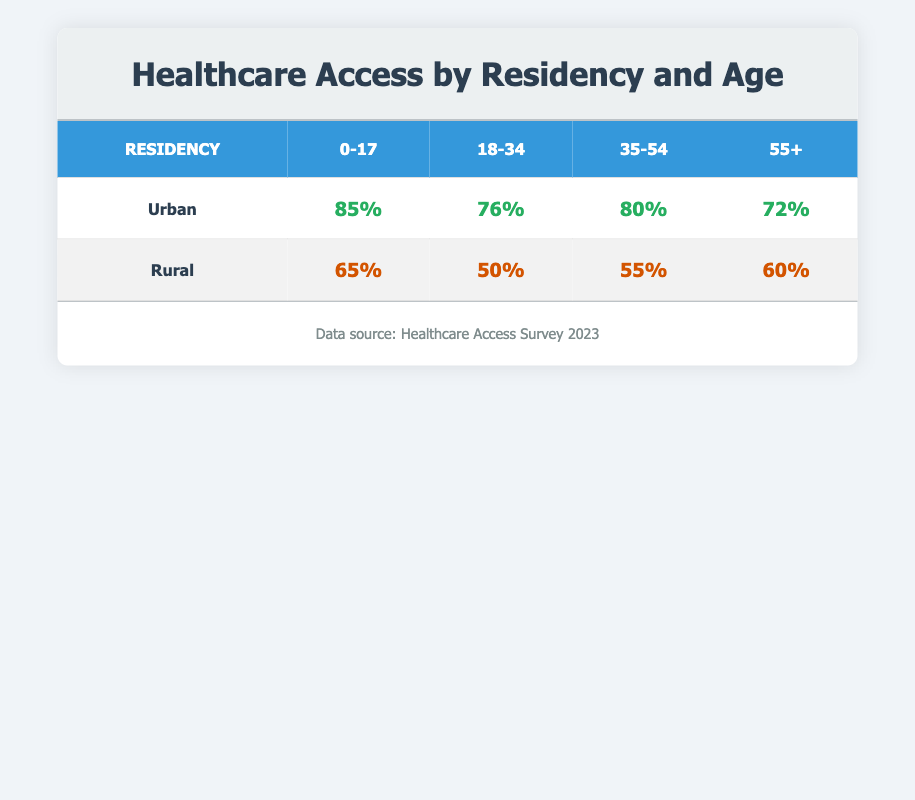What is the healthcare access percentage for Urban residents aged 0-17? The table shows that Urban residents in the age group 0-17 have a healthcare access percentage of 85%.
Answer: 85% What is the healthcare access percentage for Rural residents aged 18-34? According to the table, Rural residents aged 18-34 have a healthcare access percentage of 50%.
Answer: 50% Is the healthcare access for Urban residents aged 55+ higher than that for Rural residents in the same age group? The table presents that Urban residents aged 55+ have a healthcare access percentage of 72%, while Rural residents have 60%. Since 72% is greater than 60%, the statement is true.
Answer: Yes What is the difference in healthcare access percentage between Urban residents aged 0-17 and Rural residents aged 0-17? The access percentage for Urban residents aged 0-17 is 85%, and for Rural residents, it is 65%. The difference is 85% - 65% = 20%.
Answer: 20% What is the average healthcare access percentage for the Urban residency across all age groups? The percentages for Urban residents are: 85%, 76%, 80%, and 72%. Adding these gives 313%, and dividing by 4 age groups gives an average of 313% / 4 = 78.25%.
Answer: 78.25% Is the healthcare access rate for the age group 35-54 higher in Urban or Rural residency? The Urban access rate for the age group 35-54 is 80%, while the Rural rate is 55%. Since 80% is higher than 55%, Urban residency has a higher rate for this age group.
Answer: Yes What is the total healthcare access percentage for all Rural age groups combined? To find the total, add the healthcare access percentages for Rural residents: 65% (0-17) + 50% (18-34) + 55% (35-54) + 60% (55+) = 230%.
Answer: 230% Which age group has the lowest healthcare access percentage among Rural residents? The table indicates that Rural residents aged 18-34 have the lowest healthcare access percentage at 50%.
Answer: 50% How does the healthcare access for Urban residents aged 18-34 compare to that for Rural residents in the same age category? For Urban residents aged 18-34, the access rate is 76%, while for Rural it is 50%. Since 76% is greater than 50%, Urban residents have better access.
Answer: Urban residents have better access 